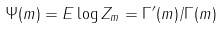<formula> <loc_0><loc_0><loc_500><loc_500>\Psi ( m ) = E \log Z _ { m } = \Gamma ^ { \prime } ( m ) / \Gamma ( m )</formula> 